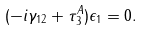Convert formula to latex. <formula><loc_0><loc_0><loc_500><loc_500>( - i \gamma _ { 1 2 } + \tau _ { 3 } ^ { A } ) \epsilon _ { 1 } = 0 .</formula> 